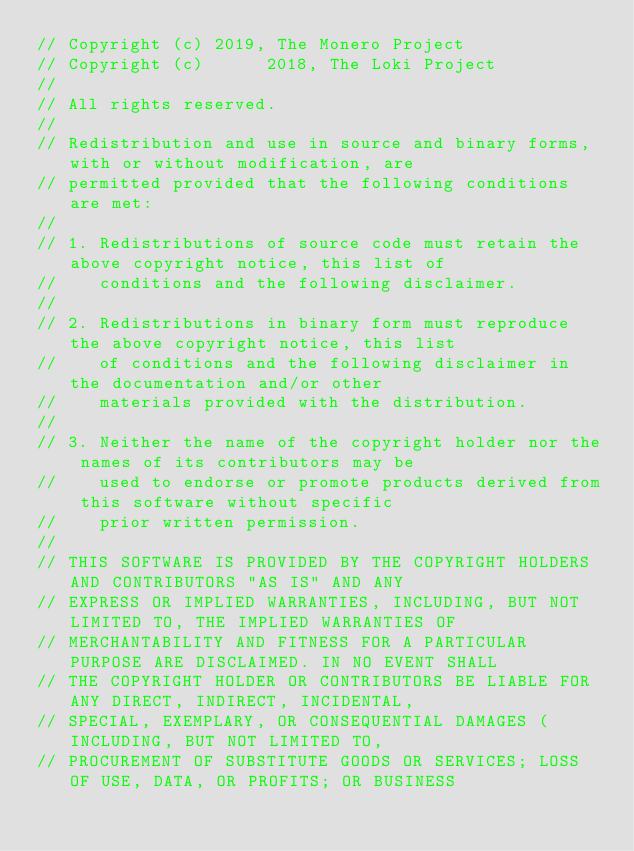<code> <loc_0><loc_0><loc_500><loc_500><_C++_>// Copyright (c) 2019, The Monero Project
// Copyright (c)      2018, The Loki Project
// 
// All rights reserved.
// 
// Redistribution and use in source and binary forms, with or without modification, are
// permitted provided that the following conditions are met:
// 
// 1. Redistributions of source code must retain the above copyright notice, this list of
//    conditions and the following disclaimer.
// 
// 2. Redistributions in binary form must reproduce the above copyright notice, this list
//    of conditions and the following disclaimer in the documentation and/or other
//    materials provided with the distribution.
// 
// 3. Neither the name of the copyright holder nor the names of its contributors may be
//    used to endorse or promote products derived from this software without specific
//    prior written permission.
// 
// THIS SOFTWARE IS PROVIDED BY THE COPYRIGHT HOLDERS AND CONTRIBUTORS "AS IS" AND ANY
// EXPRESS OR IMPLIED WARRANTIES, INCLUDING, BUT NOT LIMITED TO, THE IMPLIED WARRANTIES OF
// MERCHANTABILITY AND FITNESS FOR A PARTICULAR PURPOSE ARE DISCLAIMED. IN NO EVENT SHALL
// THE COPYRIGHT HOLDER OR CONTRIBUTORS BE LIABLE FOR ANY DIRECT, INDIRECT, INCIDENTAL,
// SPECIAL, EXEMPLARY, OR CONSEQUENTIAL DAMAGES (INCLUDING, BUT NOT LIMITED TO,
// PROCUREMENT OF SUBSTITUTE GOODS OR SERVICES; LOSS OF USE, DATA, OR PROFITS; OR BUSINESS</code> 